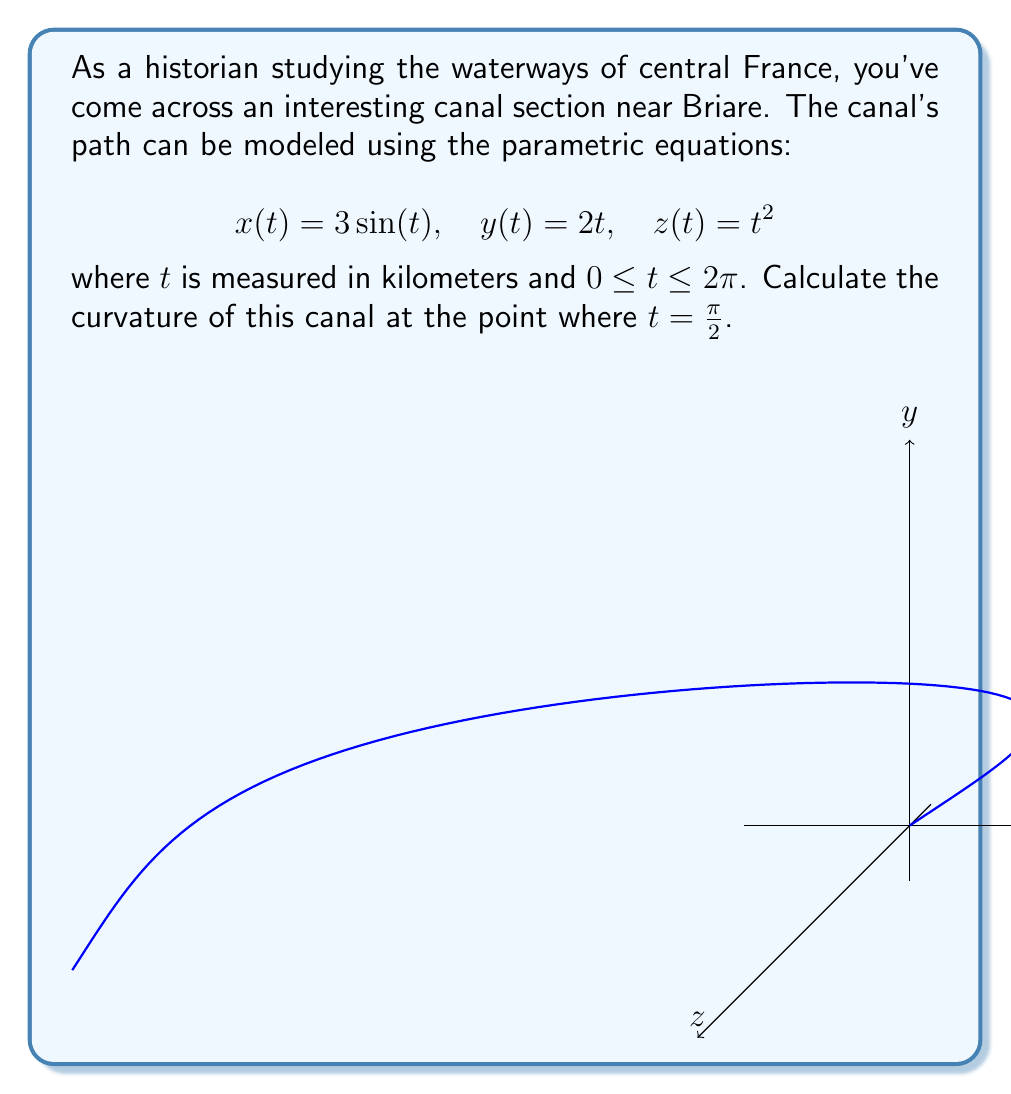Can you answer this question? To find the curvature, we'll use the formula for curvature of a parametric curve:

$$\kappa = \frac{|\mathbf{r}'(t) \times \mathbf{r}''(t)|}{|\mathbf{r}'(t)|^3}$$

Step 1: Find $\mathbf{r}'(t)$ and $\mathbf{r}''(t)$
$$\mathbf{r}'(t) = (3\cos(t), 2, 2t)$$
$$\mathbf{r}''(t) = (-3\sin(t), 0, 2)$$

Step 2: Calculate $\mathbf{r}'(t) \times \mathbf{r}''(t)$
$$\mathbf{r}'(t) \times \mathbf{r}''(t) = \begin{vmatrix} 
\mathbf{i} & \mathbf{j} & \mathbf{k} \\
3\cos(t) & 2 & 2t \\
-3\sin(t) & 0 & 2
\end{vmatrix}$$

$$= (4-4t\sin(t))\mathbf{i} + (6\cos(t))\mathbf{j} + (6\sin(t))\mathbf{k}$$

Step 3: Calculate $|\mathbf{r}'(t) \times \mathbf{r}''(t)|$ at $t = \frac{\pi}{2}$
$$|\mathbf{r}'(\frac{\pi}{2}) \times \mathbf{r}''(\frac{\pi}{2})| = \sqrt{4^2 + 0^2 + 6^2} = \sqrt{52}$$

Step 4: Calculate $|\mathbf{r}'(t)|$ at $t = \frac{\pi}{2}$
$$|\mathbf{r}'(\frac{\pi}{2})| = \sqrt{0^2 + 2^2 + \pi^2} = \sqrt{4+\pi^2}$$

Step 5: Apply the curvature formula
$$\kappa = \frac{\sqrt{52}}{(\sqrt{4+\pi^2})^3}$$
Answer: $\frac{\sqrt{52}}{(4+\pi^2)^{3/2}}$ 